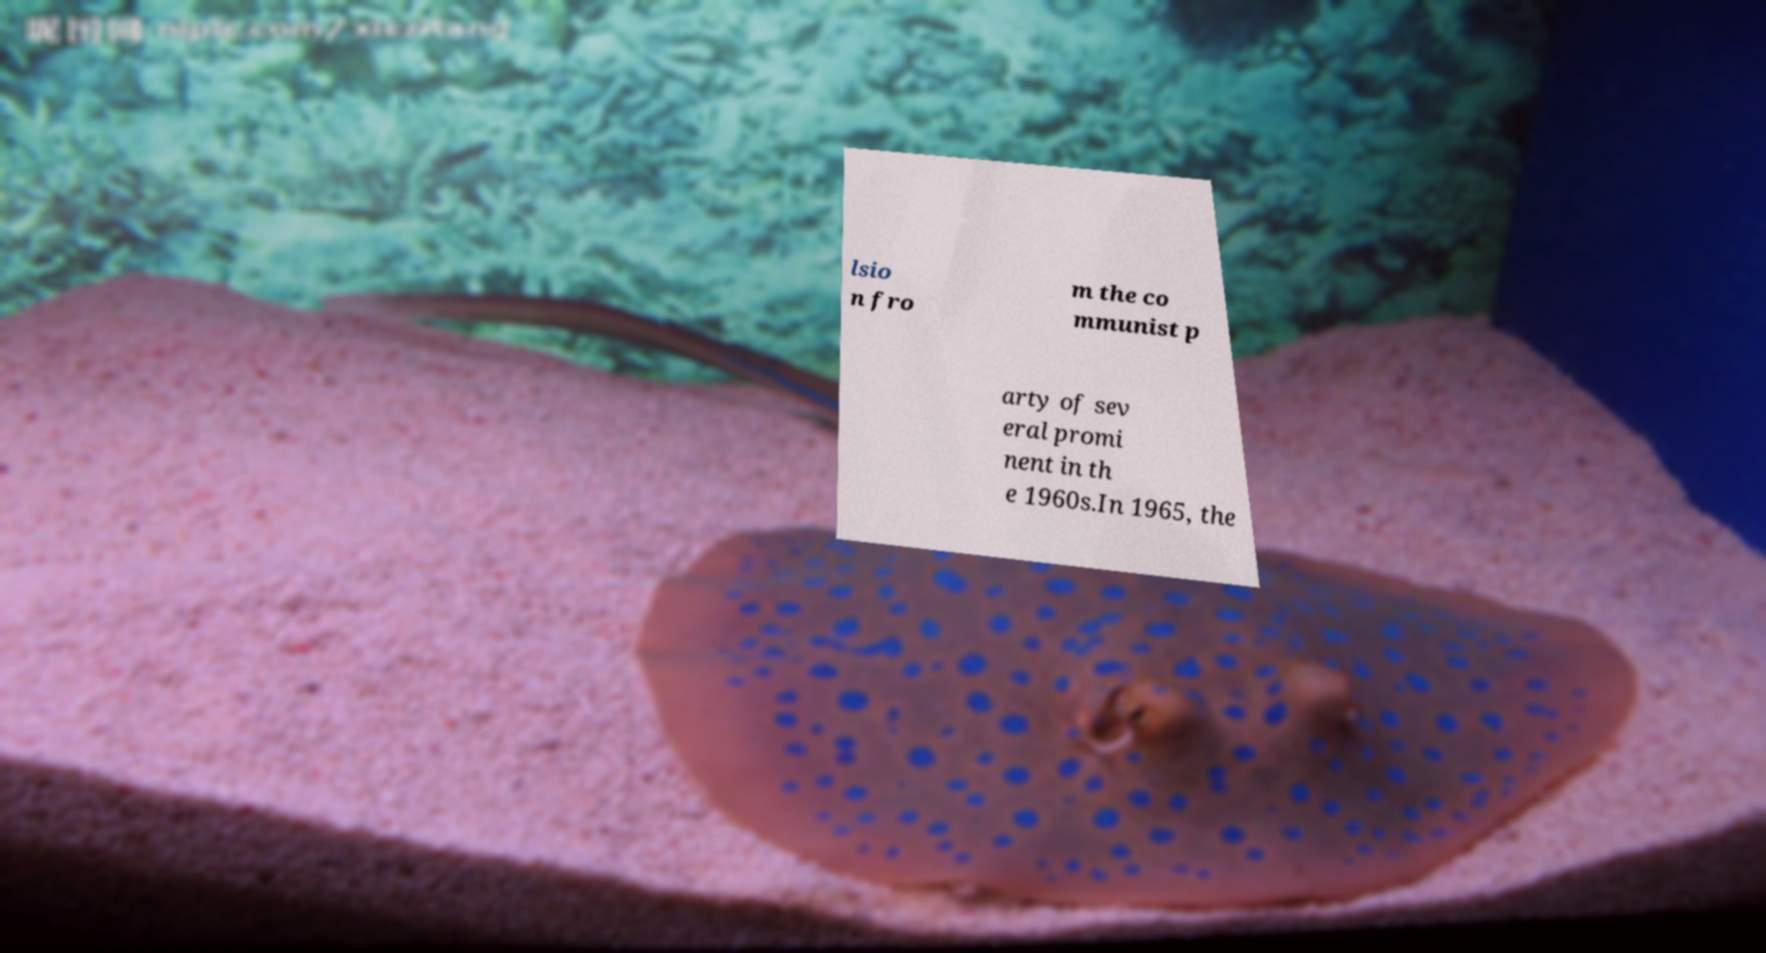Can you accurately transcribe the text from the provided image for me? lsio n fro m the co mmunist p arty of sev eral promi nent in th e 1960s.In 1965, the 